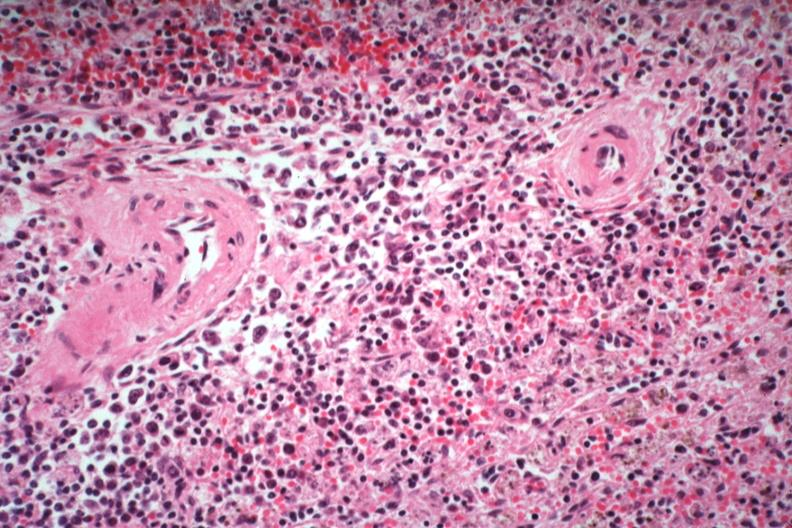what is present?
Answer the question using a single word or phrase. Immunoblastic reaction characteristic of viral infection 